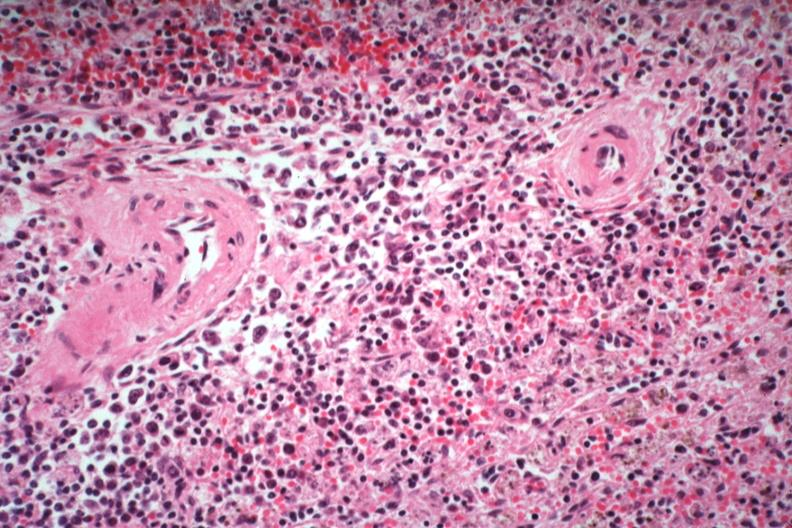what is present?
Answer the question using a single word or phrase. Immunoblastic reaction characteristic of viral infection 